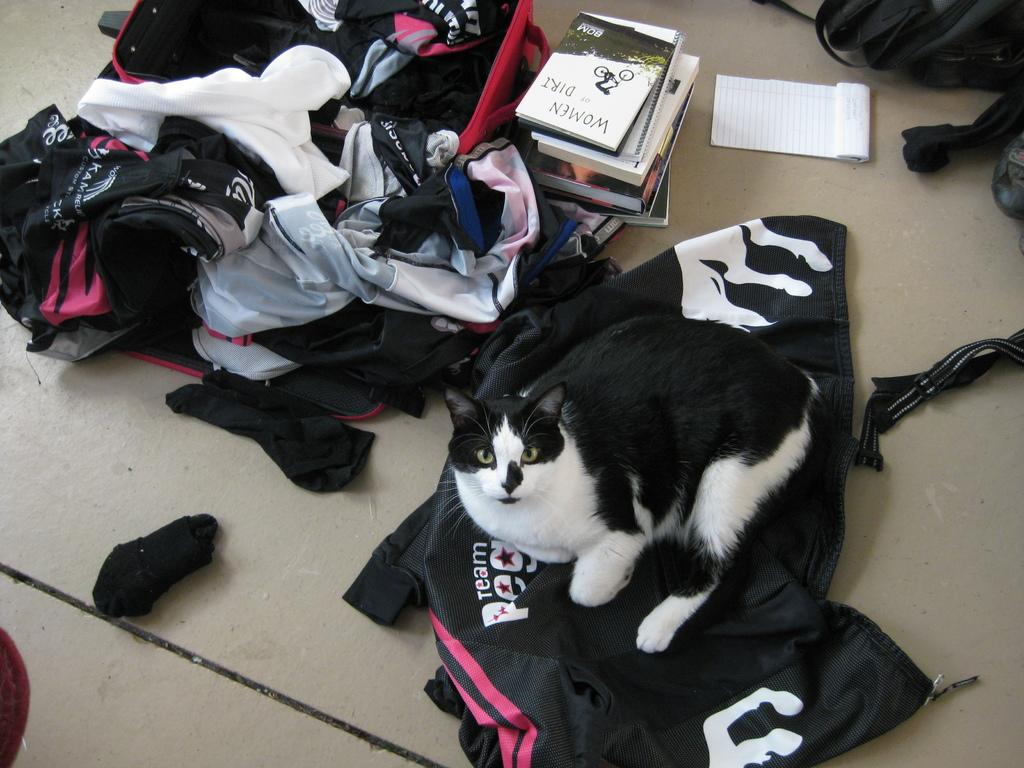What animal is sitting on an object in the image? There is a cat sitting on a bag in the image. What type of items can be seen on the floor in the image? Clothes, bags, books, and other unspecified items are visible on the floor in the image. What type of writing instrument is the mother using in the image? There is no mother or writing instrument present in the image. What color are the crayons on the floor in the image? There are no crayons present in the image. 